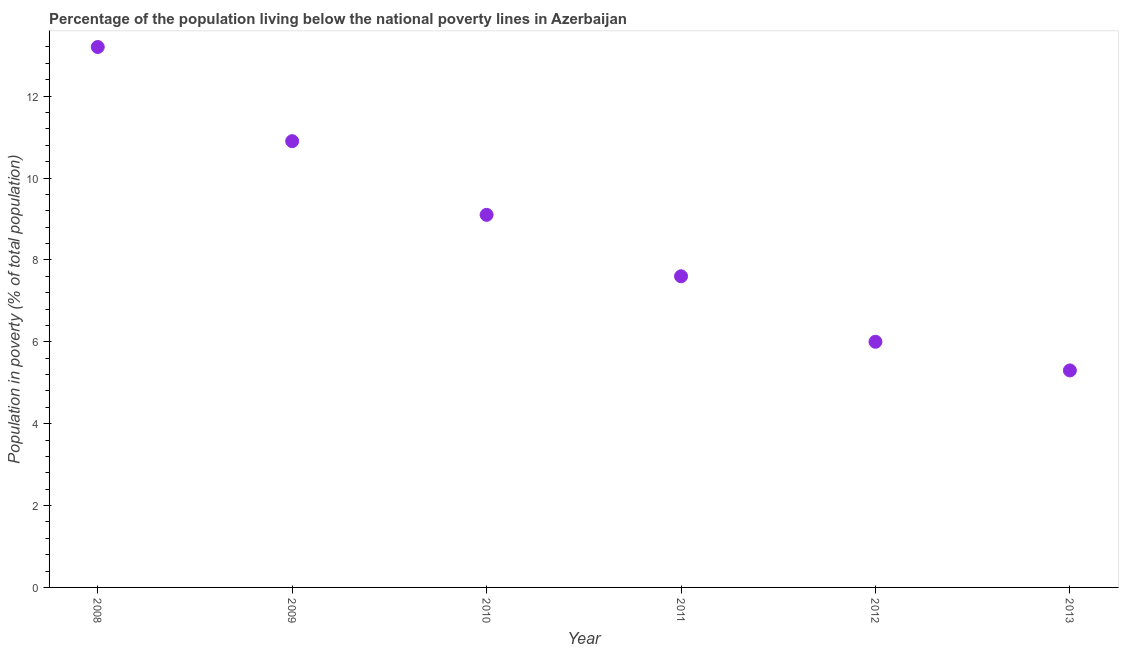Across all years, what is the maximum percentage of population living below poverty line?
Offer a terse response. 13.2. Across all years, what is the minimum percentage of population living below poverty line?
Offer a very short reply. 5.3. In which year was the percentage of population living below poverty line maximum?
Offer a very short reply. 2008. What is the sum of the percentage of population living below poverty line?
Your answer should be very brief. 52.1. What is the difference between the percentage of population living below poverty line in 2009 and 2013?
Ensure brevity in your answer.  5.6. What is the average percentage of population living below poverty line per year?
Offer a very short reply. 8.68. What is the median percentage of population living below poverty line?
Your answer should be compact. 8.35. In how many years, is the percentage of population living below poverty line greater than 1.6 %?
Provide a short and direct response. 6. Do a majority of the years between 2009 and 2013 (inclusive) have percentage of population living below poverty line greater than 8.4 %?
Your answer should be very brief. No. What is the ratio of the percentage of population living below poverty line in 2009 to that in 2011?
Ensure brevity in your answer.  1.43. Is the percentage of population living below poverty line in 2008 less than that in 2009?
Your answer should be very brief. No. Is the difference between the percentage of population living below poverty line in 2010 and 2013 greater than the difference between any two years?
Give a very brief answer. No. What is the difference between the highest and the second highest percentage of population living below poverty line?
Your response must be concise. 2.3. Is the sum of the percentage of population living below poverty line in 2009 and 2010 greater than the maximum percentage of population living below poverty line across all years?
Ensure brevity in your answer.  Yes. What is the difference between the highest and the lowest percentage of population living below poverty line?
Ensure brevity in your answer.  7.9. How many dotlines are there?
Ensure brevity in your answer.  1. How many years are there in the graph?
Your response must be concise. 6. What is the difference between two consecutive major ticks on the Y-axis?
Give a very brief answer. 2. Are the values on the major ticks of Y-axis written in scientific E-notation?
Your answer should be compact. No. Does the graph contain any zero values?
Offer a very short reply. No. What is the title of the graph?
Your response must be concise. Percentage of the population living below the national poverty lines in Azerbaijan. What is the label or title of the Y-axis?
Your answer should be very brief. Population in poverty (% of total population). What is the Population in poverty (% of total population) in 2010?
Your response must be concise. 9.1. What is the difference between the Population in poverty (% of total population) in 2008 and 2009?
Make the answer very short. 2.3. What is the difference between the Population in poverty (% of total population) in 2008 and 2012?
Keep it short and to the point. 7.2. What is the difference between the Population in poverty (% of total population) in 2011 and 2013?
Your answer should be very brief. 2.3. What is the ratio of the Population in poverty (% of total population) in 2008 to that in 2009?
Make the answer very short. 1.21. What is the ratio of the Population in poverty (% of total population) in 2008 to that in 2010?
Your response must be concise. 1.45. What is the ratio of the Population in poverty (% of total population) in 2008 to that in 2011?
Make the answer very short. 1.74. What is the ratio of the Population in poverty (% of total population) in 2008 to that in 2013?
Make the answer very short. 2.49. What is the ratio of the Population in poverty (% of total population) in 2009 to that in 2010?
Your response must be concise. 1.2. What is the ratio of the Population in poverty (% of total population) in 2009 to that in 2011?
Ensure brevity in your answer.  1.43. What is the ratio of the Population in poverty (% of total population) in 2009 to that in 2012?
Your response must be concise. 1.82. What is the ratio of the Population in poverty (% of total population) in 2009 to that in 2013?
Provide a short and direct response. 2.06. What is the ratio of the Population in poverty (% of total population) in 2010 to that in 2011?
Your response must be concise. 1.2. What is the ratio of the Population in poverty (% of total population) in 2010 to that in 2012?
Provide a short and direct response. 1.52. What is the ratio of the Population in poverty (% of total population) in 2010 to that in 2013?
Your answer should be compact. 1.72. What is the ratio of the Population in poverty (% of total population) in 2011 to that in 2012?
Your answer should be very brief. 1.27. What is the ratio of the Population in poverty (% of total population) in 2011 to that in 2013?
Keep it short and to the point. 1.43. What is the ratio of the Population in poverty (% of total population) in 2012 to that in 2013?
Give a very brief answer. 1.13. 